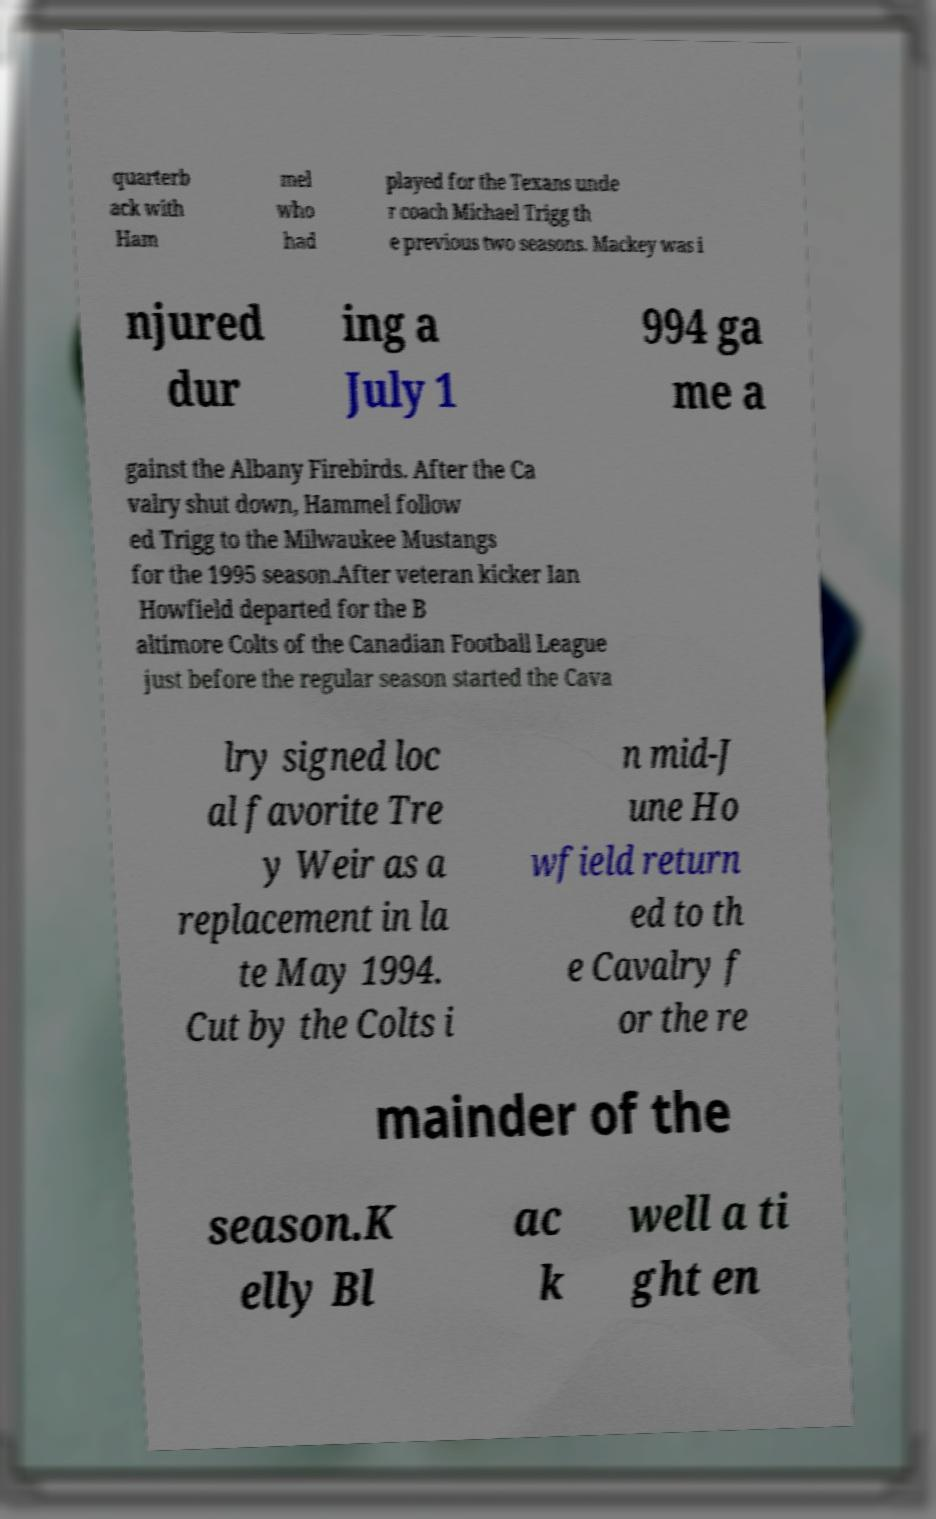Can you read and provide the text displayed in the image?This photo seems to have some interesting text. Can you extract and type it out for me? quarterb ack with Ham mel who had played for the Texans unde r coach Michael Trigg th e previous two seasons. Mackey was i njured dur ing a July 1 994 ga me a gainst the Albany Firebirds. After the Ca valry shut down, Hammel follow ed Trigg to the Milwaukee Mustangs for the 1995 season.After veteran kicker Ian Howfield departed for the B altimore Colts of the Canadian Football League just before the regular season started the Cava lry signed loc al favorite Tre y Weir as a replacement in la te May 1994. Cut by the Colts i n mid-J une Ho wfield return ed to th e Cavalry f or the re mainder of the season.K elly Bl ac k well a ti ght en 